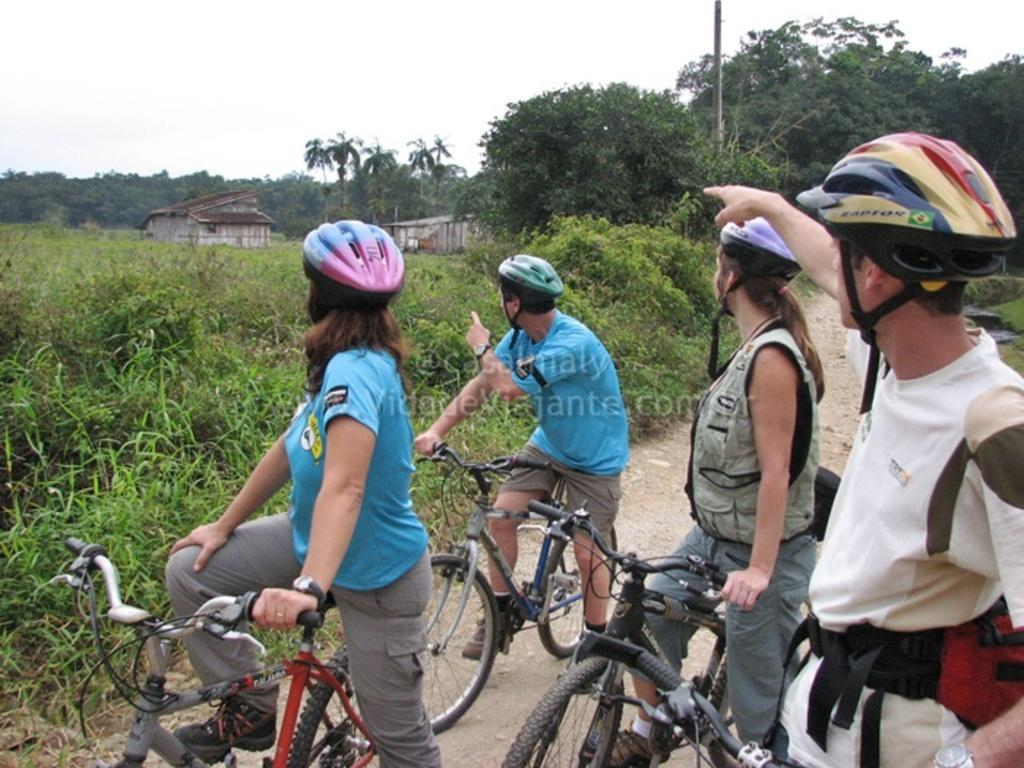How many people are in the image? There are four persons in the image. What are the people doing in the image? Each person is riding a bicycle. What safety precaution are the people taking while riding their bicycles? Each person is wearing a helmet. What can be seen in the background of the image? There are plants, houses, an electric pole, and the sky visible in the background of the image. What type of vase can be seen in the image? There is no vase present in the image. How much money is each person carrying while riding their bicycles? There is no indication of money or any financial transactions in the image. 